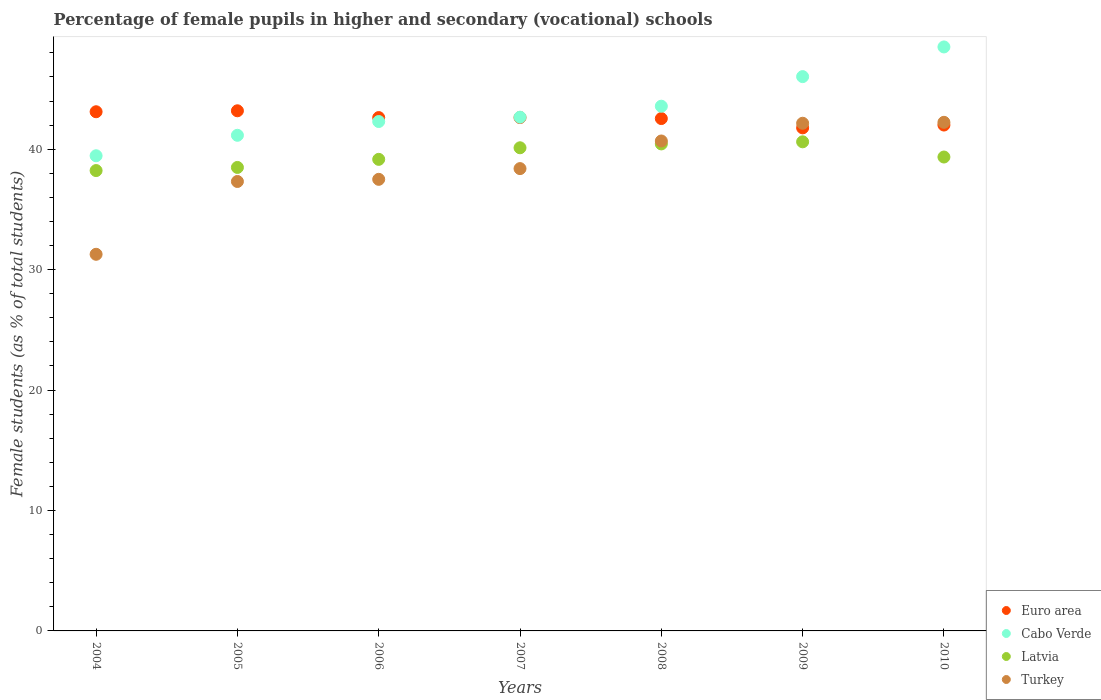How many different coloured dotlines are there?
Your answer should be very brief. 4. What is the percentage of female pupils in higher and secondary schools in Cabo Verde in 2008?
Your answer should be compact. 43.57. Across all years, what is the maximum percentage of female pupils in higher and secondary schools in Turkey?
Ensure brevity in your answer.  42.24. Across all years, what is the minimum percentage of female pupils in higher and secondary schools in Euro area?
Offer a terse response. 41.77. In which year was the percentage of female pupils in higher and secondary schools in Turkey maximum?
Offer a very short reply. 2010. What is the total percentage of female pupils in higher and secondary schools in Cabo Verde in the graph?
Offer a terse response. 303.68. What is the difference between the percentage of female pupils in higher and secondary schools in Latvia in 2004 and that in 2008?
Provide a short and direct response. -2.21. What is the difference between the percentage of female pupils in higher and secondary schools in Turkey in 2006 and the percentage of female pupils in higher and secondary schools in Latvia in 2008?
Your answer should be very brief. -2.94. What is the average percentage of female pupils in higher and secondary schools in Turkey per year?
Give a very brief answer. 38.51. In the year 2005, what is the difference between the percentage of female pupils in higher and secondary schools in Cabo Verde and percentage of female pupils in higher and secondary schools in Latvia?
Offer a terse response. 2.67. What is the ratio of the percentage of female pupils in higher and secondary schools in Turkey in 2004 to that in 2007?
Provide a short and direct response. 0.81. Is the percentage of female pupils in higher and secondary schools in Euro area in 2005 less than that in 2007?
Keep it short and to the point. No. What is the difference between the highest and the second highest percentage of female pupils in higher and secondary schools in Cabo Verde?
Offer a terse response. 2.46. What is the difference between the highest and the lowest percentage of female pupils in higher and secondary schools in Euro area?
Offer a terse response. 1.42. In how many years, is the percentage of female pupils in higher and secondary schools in Turkey greater than the average percentage of female pupils in higher and secondary schools in Turkey taken over all years?
Make the answer very short. 3. Is it the case that in every year, the sum of the percentage of female pupils in higher and secondary schools in Turkey and percentage of female pupils in higher and secondary schools in Cabo Verde  is greater than the percentage of female pupils in higher and secondary schools in Latvia?
Offer a terse response. Yes. Is the percentage of female pupils in higher and secondary schools in Latvia strictly less than the percentage of female pupils in higher and secondary schools in Turkey over the years?
Keep it short and to the point. No. How many years are there in the graph?
Offer a very short reply. 7. Where does the legend appear in the graph?
Offer a terse response. Bottom right. What is the title of the graph?
Offer a very short reply. Percentage of female pupils in higher and secondary (vocational) schools. Does "Tuvalu" appear as one of the legend labels in the graph?
Offer a very short reply. No. What is the label or title of the X-axis?
Offer a terse response. Years. What is the label or title of the Y-axis?
Offer a terse response. Female students (as % of total students). What is the Female students (as % of total students) in Euro area in 2004?
Your response must be concise. 43.11. What is the Female students (as % of total students) of Cabo Verde in 2004?
Provide a short and direct response. 39.46. What is the Female students (as % of total students) in Latvia in 2004?
Your answer should be compact. 38.23. What is the Female students (as % of total students) in Turkey in 2004?
Make the answer very short. 31.28. What is the Female students (as % of total students) in Euro area in 2005?
Offer a terse response. 43.19. What is the Female students (as % of total students) of Cabo Verde in 2005?
Ensure brevity in your answer.  41.16. What is the Female students (as % of total students) of Latvia in 2005?
Offer a terse response. 38.49. What is the Female students (as % of total students) in Turkey in 2005?
Give a very brief answer. 37.32. What is the Female students (as % of total students) of Euro area in 2006?
Your answer should be compact. 42.63. What is the Female students (as % of total students) of Cabo Verde in 2006?
Make the answer very short. 42.3. What is the Female students (as % of total students) of Latvia in 2006?
Your response must be concise. 39.16. What is the Female students (as % of total students) of Turkey in 2006?
Offer a very short reply. 37.5. What is the Female students (as % of total students) of Euro area in 2007?
Provide a succinct answer. 42.63. What is the Female students (as % of total students) of Cabo Verde in 2007?
Your answer should be very brief. 42.66. What is the Female students (as % of total students) in Latvia in 2007?
Provide a short and direct response. 40.12. What is the Female students (as % of total students) in Turkey in 2007?
Your answer should be very brief. 38.39. What is the Female students (as % of total students) of Euro area in 2008?
Keep it short and to the point. 42.55. What is the Female students (as % of total students) of Cabo Verde in 2008?
Offer a terse response. 43.57. What is the Female students (as % of total students) in Latvia in 2008?
Your response must be concise. 40.44. What is the Female students (as % of total students) in Turkey in 2008?
Make the answer very short. 40.69. What is the Female students (as % of total students) of Euro area in 2009?
Your answer should be very brief. 41.77. What is the Female students (as % of total students) of Cabo Verde in 2009?
Offer a very short reply. 46.03. What is the Female students (as % of total students) of Latvia in 2009?
Keep it short and to the point. 40.62. What is the Female students (as % of total students) in Turkey in 2009?
Make the answer very short. 42.16. What is the Female students (as % of total students) in Euro area in 2010?
Offer a very short reply. 42.01. What is the Female students (as % of total students) of Cabo Verde in 2010?
Provide a short and direct response. 48.5. What is the Female students (as % of total students) in Latvia in 2010?
Your answer should be compact. 39.35. What is the Female students (as % of total students) of Turkey in 2010?
Provide a short and direct response. 42.24. Across all years, what is the maximum Female students (as % of total students) of Euro area?
Offer a terse response. 43.19. Across all years, what is the maximum Female students (as % of total students) in Cabo Verde?
Make the answer very short. 48.5. Across all years, what is the maximum Female students (as % of total students) in Latvia?
Your answer should be compact. 40.62. Across all years, what is the maximum Female students (as % of total students) of Turkey?
Ensure brevity in your answer.  42.24. Across all years, what is the minimum Female students (as % of total students) in Euro area?
Your answer should be very brief. 41.77. Across all years, what is the minimum Female students (as % of total students) of Cabo Verde?
Make the answer very short. 39.46. Across all years, what is the minimum Female students (as % of total students) in Latvia?
Offer a very short reply. 38.23. Across all years, what is the minimum Female students (as % of total students) in Turkey?
Make the answer very short. 31.28. What is the total Female students (as % of total students) of Euro area in the graph?
Make the answer very short. 297.9. What is the total Female students (as % of total students) of Cabo Verde in the graph?
Offer a very short reply. 303.68. What is the total Female students (as % of total students) in Latvia in the graph?
Give a very brief answer. 276.41. What is the total Female students (as % of total students) of Turkey in the graph?
Provide a succinct answer. 269.57. What is the difference between the Female students (as % of total students) of Euro area in 2004 and that in 2005?
Offer a very short reply. -0.08. What is the difference between the Female students (as % of total students) in Cabo Verde in 2004 and that in 2005?
Offer a very short reply. -1.7. What is the difference between the Female students (as % of total students) of Latvia in 2004 and that in 2005?
Your answer should be compact. -0.26. What is the difference between the Female students (as % of total students) of Turkey in 2004 and that in 2005?
Keep it short and to the point. -6.05. What is the difference between the Female students (as % of total students) of Euro area in 2004 and that in 2006?
Give a very brief answer. 0.48. What is the difference between the Female students (as % of total students) in Cabo Verde in 2004 and that in 2006?
Ensure brevity in your answer.  -2.84. What is the difference between the Female students (as % of total students) in Latvia in 2004 and that in 2006?
Offer a terse response. -0.93. What is the difference between the Female students (as % of total students) in Turkey in 2004 and that in 2006?
Offer a very short reply. -6.22. What is the difference between the Female students (as % of total students) in Euro area in 2004 and that in 2007?
Provide a succinct answer. 0.48. What is the difference between the Female students (as % of total students) of Cabo Verde in 2004 and that in 2007?
Your answer should be very brief. -3.2. What is the difference between the Female students (as % of total students) of Latvia in 2004 and that in 2007?
Your response must be concise. -1.89. What is the difference between the Female students (as % of total students) in Turkey in 2004 and that in 2007?
Your answer should be very brief. -7.12. What is the difference between the Female students (as % of total students) in Euro area in 2004 and that in 2008?
Your answer should be compact. 0.57. What is the difference between the Female students (as % of total students) of Cabo Verde in 2004 and that in 2008?
Your answer should be very brief. -4.11. What is the difference between the Female students (as % of total students) of Latvia in 2004 and that in 2008?
Make the answer very short. -2.21. What is the difference between the Female students (as % of total students) in Turkey in 2004 and that in 2008?
Provide a succinct answer. -9.41. What is the difference between the Female students (as % of total students) of Euro area in 2004 and that in 2009?
Give a very brief answer. 1.34. What is the difference between the Female students (as % of total students) in Cabo Verde in 2004 and that in 2009?
Provide a short and direct response. -6.57. What is the difference between the Female students (as % of total students) in Latvia in 2004 and that in 2009?
Your response must be concise. -2.39. What is the difference between the Female students (as % of total students) of Turkey in 2004 and that in 2009?
Keep it short and to the point. -10.88. What is the difference between the Female students (as % of total students) of Euro area in 2004 and that in 2010?
Offer a terse response. 1.1. What is the difference between the Female students (as % of total students) of Cabo Verde in 2004 and that in 2010?
Ensure brevity in your answer.  -9.04. What is the difference between the Female students (as % of total students) of Latvia in 2004 and that in 2010?
Keep it short and to the point. -1.12. What is the difference between the Female students (as % of total students) of Turkey in 2004 and that in 2010?
Your answer should be very brief. -10.96. What is the difference between the Female students (as % of total students) in Euro area in 2005 and that in 2006?
Keep it short and to the point. 0.56. What is the difference between the Female students (as % of total students) in Cabo Verde in 2005 and that in 2006?
Provide a short and direct response. -1.14. What is the difference between the Female students (as % of total students) of Latvia in 2005 and that in 2006?
Your response must be concise. -0.67. What is the difference between the Female students (as % of total students) in Turkey in 2005 and that in 2006?
Keep it short and to the point. -0.18. What is the difference between the Female students (as % of total students) of Euro area in 2005 and that in 2007?
Ensure brevity in your answer.  0.56. What is the difference between the Female students (as % of total students) in Cabo Verde in 2005 and that in 2007?
Ensure brevity in your answer.  -1.5. What is the difference between the Female students (as % of total students) of Latvia in 2005 and that in 2007?
Ensure brevity in your answer.  -1.63. What is the difference between the Female students (as % of total students) of Turkey in 2005 and that in 2007?
Provide a succinct answer. -1.07. What is the difference between the Female students (as % of total students) of Euro area in 2005 and that in 2008?
Provide a succinct answer. 0.65. What is the difference between the Female students (as % of total students) in Cabo Verde in 2005 and that in 2008?
Your answer should be very brief. -2.42. What is the difference between the Female students (as % of total students) in Latvia in 2005 and that in 2008?
Your answer should be compact. -1.95. What is the difference between the Female students (as % of total students) in Turkey in 2005 and that in 2008?
Your answer should be very brief. -3.36. What is the difference between the Female students (as % of total students) of Euro area in 2005 and that in 2009?
Your answer should be very brief. 1.42. What is the difference between the Female students (as % of total students) in Cabo Verde in 2005 and that in 2009?
Ensure brevity in your answer.  -4.87. What is the difference between the Female students (as % of total students) of Latvia in 2005 and that in 2009?
Your answer should be very brief. -2.13. What is the difference between the Female students (as % of total students) in Turkey in 2005 and that in 2009?
Your response must be concise. -4.84. What is the difference between the Female students (as % of total students) of Euro area in 2005 and that in 2010?
Offer a very short reply. 1.18. What is the difference between the Female students (as % of total students) of Cabo Verde in 2005 and that in 2010?
Keep it short and to the point. -7.34. What is the difference between the Female students (as % of total students) of Latvia in 2005 and that in 2010?
Ensure brevity in your answer.  -0.86. What is the difference between the Female students (as % of total students) of Turkey in 2005 and that in 2010?
Make the answer very short. -4.91. What is the difference between the Female students (as % of total students) in Euro area in 2006 and that in 2007?
Ensure brevity in your answer.  -0. What is the difference between the Female students (as % of total students) of Cabo Verde in 2006 and that in 2007?
Offer a terse response. -0.36. What is the difference between the Female students (as % of total students) of Latvia in 2006 and that in 2007?
Your answer should be compact. -0.96. What is the difference between the Female students (as % of total students) in Turkey in 2006 and that in 2007?
Provide a succinct answer. -0.89. What is the difference between the Female students (as % of total students) of Euro area in 2006 and that in 2008?
Give a very brief answer. 0.08. What is the difference between the Female students (as % of total students) in Cabo Verde in 2006 and that in 2008?
Provide a short and direct response. -1.27. What is the difference between the Female students (as % of total students) of Latvia in 2006 and that in 2008?
Your answer should be very brief. -1.28. What is the difference between the Female students (as % of total students) in Turkey in 2006 and that in 2008?
Give a very brief answer. -3.18. What is the difference between the Female students (as % of total students) of Euro area in 2006 and that in 2009?
Keep it short and to the point. 0.85. What is the difference between the Female students (as % of total students) in Cabo Verde in 2006 and that in 2009?
Offer a very short reply. -3.73. What is the difference between the Female students (as % of total students) of Latvia in 2006 and that in 2009?
Provide a short and direct response. -1.46. What is the difference between the Female students (as % of total students) in Turkey in 2006 and that in 2009?
Offer a very short reply. -4.66. What is the difference between the Female students (as % of total students) of Euro area in 2006 and that in 2010?
Provide a short and direct response. 0.62. What is the difference between the Female students (as % of total students) in Cabo Verde in 2006 and that in 2010?
Ensure brevity in your answer.  -6.19. What is the difference between the Female students (as % of total students) in Latvia in 2006 and that in 2010?
Offer a very short reply. -0.19. What is the difference between the Female students (as % of total students) of Turkey in 2006 and that in 2010?
Offer a terse response. -4.73. What is the difference between the Female students (as % of total students) in Euro area in 2007 and that in 2008?
Your response must be concise. 0.08. What is the difference between the Female students (as % of total students) in Cabo Verde in 2007 and that in 2008?
Keep it short and to the point. -0.91. What is the difference between the Female students (as % of total students) in Latvia in 2007 and that in 2008?
Offer a very short reply. -0.32. What is the difference between the Female students (as % of total students) in Turkey in 2007 and that in 2008?
Ensure brevity in your answer.  -2.29. What is the difference between the Female students (as % of total students) of Euro area in 2007 and that in 2009?
Offer a very short reply. 0.86. What is the difference between the Female students (as % of total students) in Cabo Verde in 2007 and that in 2009?
Offer a terse response. -3.37. What is the difference between the Female students (as % of total students) in Latvia in 2007 and that in 2009?
Make the answer very short. -0.5. What is the difference between the Female students (as % of total students) of Turkey in 2007 and that in 2009?
Provide a short and direct response. -3.77. What is the difference between the Female students (as % of total students) in Euro area in 2007 and that in 2010?
Provide a succinct answer. 0.62. What is the difference between the Female students (as % of total students) in Cabo Verde in 2007 and that in 2010?
Keep it short and to the point. -5.83. What is the difference between the Female students (as % of total students) in Latvia in 2007 and that in 2010?
Give a very brief answer. 0.77. What is the difference between the Female students (as % of total students) in Turkey in 2007 and that in 2010?
Keep it short and to the point. -3.84. What is the difference between the Female students (as % of total students) in Euro area in 2008 and that in 2009?
Keep it short and to the point. 0.77. What is the difference between the Female students (as % of total students) of Cabo Verde in 2008 and that in 2009?
Provide a short and direct response. -2.46. What is the difference between the Female students (as % of total students) of Latvia in 2008 and that in 2009?
Provide a succinct answer. -0.17. What is the difference between the Female students (as % of total students) in Turkey in 2008 and that in 2009?
Give a very brief answer. -1.47. What is the difference between the Female students (as % of total students) in Euro area in 2008 and that in 2010?
Your answer should be very brief. 0.54. What is the difference between the Female students (as % of total students) in Cabo Verde in 2008 and that in 2010?
Provide a short and direct response. -4.92. What is the difference between the Female students (as % of total students) of Latvia in 2008 and that in 2010?
Provide a succinct answer. 1.09. What is the difference between the Female students (as % of total students) of Turkey in 2008 and that in 2010?
Give a very brief answer. -1.55. What is the difference between the Female students (as % of total students) in Euro area in 2009 and that in 2010?
Offer a terse response. -0.23. What is the difference between the Female students (as % of total students) of Cabo Verde in 2009 and that in 2010?
Offer a very short reply. -2.46. What is the difference between the Female students (as % of total students) of Latvia in 2009 and that in 2010?
Give a very brief answer. 1.26. What is the difference between the Female students (as % of total students) of Turkey in 2009 and that in 2010?
Give a very brief answer. -0.08. What is the difference between the Female students (as % of total students) in Euro area in 2004 and the Female students (as % of total students) in Cabo Verde in 2005?
Keep it short and to the point. 1.96. What is the difference between the Female students (as % of total students) of Euro area in 2004 and the Female students (as % of total students) of Latvia in 2005?
Ensure brevity in your answer.  4.62. What is the difference between the Female students (as % of total students) of Euro area in 2004 and the Female students (as % of total students) of Turkey in 2005?
Your answer should be very brief. 5.79. What is the difference between the Female students (as % of total students) in Cabo Verde in 2004 and the Female students (as % of total students) in Latvia in 2005?
Provide a short and direct response. 0.97. What is the difference between the Female students (as % of total students) of Cabo Verde in 2004 and the Female students (as % of total students) of Turkey in 2005?
Your answer should be very brief. 2.14. What is the difference between the Female students (as % of total students) of Latvia in 2004 and the Female students (as % of total students) of Turkey in 2005?
Keep it short and to the point. 0.91. What is the difference between the Female students (as % of total students) in Euro area in 2004 and the Female students (as % of total students) in Cabo Verde in 2006?
Your answer should be compact. 0.81. What is the difference between the Female students (as % of total students) of Euro area in 2004 and the Female students (as % of total students) of Latvia in 2006?
Give a very brief answer. 3.95. What is the difference between the Female students (as % of total students) in Euro area in 2004 and the Female students (as % of total students) in Turkey in 2006?
Ensure brevity in your answer.  5.61. What is the difference between the Female students (as % of total students) of Cabo Verde in 2004 and the Female students (as % of total students) of Latvia in 2006?
Provide a succinct answer. 0.3. What is the difference between the Female students (as % of total students) of Cabo Verde in 2004 and the Female students (as % of total students) of Turkey in 2006?
Your answer should be very brief. 1.96. What is the difference between the Female students (as % of total students) in Latvia in 2004 and the Female students (as % of total students) in Turkey in 2006?
Your answer should be compact. 0.73. What is the difference between the Female students (as % of total students) in Euro area in 2004 and the Female students (as % of total students) in Cabo Verde in 2007?
Your answer should be compact. 0.45. What is the difference between the Female students (as % of total students) of Euro area in 2004 and the Female students (as % of total students) of Latvia in 2007?
Keep it short and to the point. 2.99. What is the difference between the Female students (as % of total students) of Euro area in 2004 and the Female students (as % of total students) of Turkey in 2007?
Your response must be concise. 4.72. What is the difference between the Female students (as % of total students) in Cabo Verde in 2004 and the Female students (as % of total students) in Latvia in 2007?
Your answer should be compact. -0.66. What is the difference between the Female students (as % of total students) in Cabo Verde in 2004 and the Female students (as % of total students) in Turkey in 2007?
Keep it short and to the point. 1.07. What is the difference between the Female students (as % of total students) in Latvia in 2004 and the Female students (as % of total students) in Turkey in 2007?
Make the answer very short. -0.16. What is the difference between the Female students (as % of total students) of Euro area in 2004 and the Female students (as % of total students) of Cabo Verde in 2008?
Ensure brevity in your answer.  -0.46. What is the difference between the Female students (as % of total students) in Euro area in 2004 and the Female students (as % of total students) in Latvia in 2008?
Your response must be concise. 2.67. What is the difference between the Female students (as % of total students) of Euro area in 2004 and the Female students (as % of total students) of Turkey in 2008?
Your answer should be very brief. 2.43. What is the difference between the Female students (as % of total students) in Cabo Verde in 2004 and the Female students (as % of total students) in Latvia in 2008?
Provide a short and direct response. -0.98. What is the difference between the Female students (as % of total students) in Cabo Verde in 2004 and the Female students (as % of total students) in Turkey in 2008?
Keep it short and to the point. -1.23. What is the difference between the Female students (as % of total students) in Latvia in 2004 and the Female students (as % of total students) in Turkey in 2008?
Give a very brief answer. -2.46. What is the difference between the Female students (as % of total students) in Euro area in 2004 and the Female students (as % of total students) in Cabo Verde in 2009?
Offer a terse response. -2.92. What is the difference between the Female students (as % of total students) in Euro area in 2004 and the Female students (as % of total students) in Latvia in 2009?
Ensure brevity in your answer.  2.5. What is the difference between the Female students (as % of total students) in Euro area in 2004 and the Female students (as % of total students) in Turkey in 2009?
Give a very brief answer. 0.95. What is the difference between the Female students (as % of total students) of Cabo Verde in 2004 and the Female students (as % of total students) of Latvia in 2009?
Offer a very short reply. -1.16. What is the difference between the Female students (as % of total students) in Cabo Verde in 2004 and the Female students (as % of total students) in Turkey in 2009?
Your answer should be very brief. -2.7. What is the difference between the Female students (as % of total students) of Latvia in 2004 and the Female students (as % of total students) of Turkey in 2009?
Offer a terse response. -3.93. What is the difference between the Female students (as % of total students) in Euro area in 2004 and the Female students (as % of total students) in Cabo Verde in 2010?
Make the answer very short. -5.38. What is the difference between the Female students (as % of total students) in Euro area in 2004 and the Female students (as % of total students) in Latvia in 2010?
Your answer should be compact. 3.76. What is the difference between the Female students (as % of total students) in Euro area in 2004 and the Female students (as % of total students) in Turkey in 2010?
Provide a short and direct response. 0.88. What is the difference between the Female students (as % of total students) of Cabo Verde in 2004 and the Female students (as % of total students) of Latvia in 2010?
Your response must be concise. 0.11. What is the difference between the Female students (as % of total students) of Cabo Verde in 2004 and the Female students (as % of total students) of Turkey in 2010?
Provide a succinct answer. -2.78. What is the difference between the Female students (as % of total students) of Latvia in 2004 and the Female students (as % of total students) of Turkey in 2010?
Offer a terse response. -4.01. What is the difference between the Female students (as % of total students) of Euro area in 2005 and the Female students (as % of total students) of Cabo Verde in 2006?
Provide a succinct answer. 0.89. What is the difference between the Female students (as % of total students) in Euro area in 2005 and the Female students (as % of total students) in Latvia in 2006?
Make the answer very short. 4.03. What is the difference between the Female students (as % of total students) of Euro area in 2005 and the Female students (as % of total students) of Turkey in 2006?
Provide a short and direct response. 5.69. What is the difference between the Female students (as % of total students) in Cabo Verde in 2005 and the Female students (as % of total students) in Latvia in 2006?
Your answer should be compact. 2. What is the difference between the Female students (as % of total students) in Cabo Verde in 2005 and the Female students (as % of total students) in Turkey in 2006?
Provide a short and direct response. 3.66. What is the difference between the Female students (as % of total students) in Euro area in 2005 and the Female students (as % of total students) in Cabo Verde in 2007?
Keep it short and to the point. 0.53. What is the difference between the Female students (as % of total students) of Euro area in 2005 and the Female students (as % of total students) of Latvia in 2007?
Provide a succinct answer. 3.07. What is the difference between the Female students (as % of total students) of Euro area in 2005 and the Female students (as % of total students) of Turkey in 2007?
Your response must be concise. 4.8. What is the difference between the Female students (as % of total students) in Cabo Verde in 2005 and the Female students (as % of total students) in Latvia in 2007?
Offer a very short reply. 1.04. What is the difference between the Female students (as % of total students) of Cabo Verde in 2005 and the Female students (as % of total students) of Turkey in 2007?
Make the answer very short. 2.77. What is the difference between the Female students (as % of total students) in Latvia in 2005 and the Female students (as % of total students) in Turkey in 2007?
Provide a succinct answer. 0.1. What is the difference between the Female students (as % of total students) of Euro area in 2005 and the Female students (as % of total students) of Cabo Verde in 2008?
Make the answer very short. -0.38. What is the difference between the Female students (as % of total students) in Euro area in 2005 and the Female students (as % of total students) in Latvia in 2008?
Keep it short and to the point. 2.75. What is the difference between the Female students (as % of total students) in Euro area in 2005 and the Female students (as % of total students) in Turkey in 2008?
Offer a very short reply. 2.51. What is the difference between the Female students (as % of total students) of Cabo Verde in 2005 and the Female students (as % of total students) of Latvia in 2008?
Offer a terse response. 0.72. What is the difference between the Female students (as % of total students) of Cabo Verde in 2005 and the Female students (as % of total students) of Turkey in 2008?
Your answer should be compact. 0.47. What is the difference between the Female students (as % of total students) in Latvia in 2005 and the Female students (as % of total students) in Turkey in 2008?
Ensure brevity in your answer.  -2.2. What is the difference between the Female students (as % of total students) in Euro area in 2005 and the Female students (as % of total students) in Cabo Verde in 2009?
Offer a very short reply. -2.84. What is the difference between the Female students (as % of total students) of Euro area in 2005 and the Female students (as % of total students) of Latvia in 2009?
Give a very brief answer. 2.58. What is the difference between the Female students (as % of total students) in Euro area in 2005 and the Female students (as % of total students) in Turkey in 2009?
Your response must be concise. 1.03. What is the difference between the Female students (as % of total students) of Cabo Verde in 2005 and the Female students (as % of total students) of Latvia in 2009?
Your answer should be compact. 0.54. What is the difference between the Female students (as % of total students) in Cabo Verde in 2005 and the Female students (as % of total students) in Turkey in 2009?
Your answer should be compact. -1. What is the difference between the Female students (as % of total students) of Latvia in 2005 and the Female students (as % of total students) of Turkey in 2009?
Ensure brevity in your answer.  -3.67. What is the difference between the Female students (as % of total students) in Euro area in 2005 and the Female students (as % of total students) in Cabo Verde in 2010?
Provide a succinct answer. -5.3. What is the difference between the Female students (as % of total students) of Euro area in 2005 and the Female students (as % of total students) of Latvia in 2010?
Keep it short and to the point. 3.84. What is the difference between the Female students (as % of total students) in Euro area in 2005 and the Female students (as % of total students) in Turkey in 2010?
Your answer should be very brief. 0.96. What is the difference between the Female students (as % of total students) in Cabo Verde in 2005 and the Female students (as % of total students) in Latvia in 2010?
Your response must be concise. 1.8. What is the difference between the Female students (as % of total students) of Cabo Verde in 2005 and the Female students (as % of total students) of Turkey in 2010?
Offer a terse response. -1.08. What is the difference between the Female students (as % of total students) of Latvia in 2005 and the Female students (as % of total students) of Turkey in 2010?
Your answer should be very brief. -3.75. What is the difference between the Female students (as % of total students) of Euro area in 2006 and the Female students (as % of total students) of Cabo Verde in 2007?
Provide a succinct answer. -0.03. What is the difference between the Female students (as % of total students) of Euro area in 2006 and the Female students (as % of total students) of Latvia in 2007?
Your answer should be compact. 2.51. What is the difference between the Female students (as % of total students) of Euro area in 2006 and the Female students (as % of total students) of Turkey in 2007?
Your response must be concise. 4.24. What is the difference between the Female students (as % of total students) in Cabo Verde in 2006 and the Female students (as % of total students) in Latvia in 2007?
Provide a short and direct response. 2.18. What is the difference between the Female students (as % of total students) of Cabo Verde in 2006 and the Female students (as % of total students) of Turkey in 2007?
Your response must be concise. 3.91. What is the difference between the Female students (as % of total students) of Latvia in 2006 and the Female students (as % of total students) of Turkey in 2007?
Your answer should be compact. 0.77. What is the difference between the Female students (as % of total students) of Euro area in 2006 and the Female students (as % of total students) of Cabo Verde in 2008?
Your answer should be compact. -0.94. What is the difference between the Female students (as % of total students) in Euro area in 2006 and the Female students (as % of total students) in Latvia in 2008?
Offer a terse response. 2.19. What is the difference between the Female students (as % of total students) in Euro area in 2006 and the Female students (as % of total students) in Turkey in 2008?
Ensure brevity in your answer.  1.94. What is the difference between the Female students (as % of total students) of Cabo Verde in 2006 and the Female students (as % of total students) of Latvia in 2008?
Your response must be concise. 1.86. What is the difference between the Female students (as % of total students) in Cabo Verde in 2006 and the Female students (as % of total students) in Turkey in 2008?
Make the answer very short. 1.62. What is the difference between the Female students (as % of total students) of Latvia in 2006 and the Female students (as % of total students) of Turkey in 2008?
Make the answer very short. -1.52. What is the difference between the Female students (as % of total students) in Euro area in 2006 and the Female students (as % of total students) in Cabo Verde in 2009?
Your response must be concise. -3.4. What is the difference between the Female students (as % of total students) in Euro area in 2006 and the Female students (as % of total students) in Latvia in 2009?
Provide a succinct answer. 2.01. What is the difference between the Female students (as % of total students) of Euro area in 2006 and the Female students (as % of total students) of Turkey in 2009?
Offer a very short reply. 0.47. What is the difference between the Female students (as % of total students) in Cabo Verde in 2006 and the Female students (as % of total students) in Latvia in 2009?
Keep it short and to the point. 1.69. What is the difference between the Female students (as % of total students) of Cabo Verde in 2006 and the Female students (as % of total students) of Turkey in 2009?
Provide a short and direct response. 0.14. What is the difference between the Female students (as % of total students) of Latvia in 2006 and the Female students (as % of total students) of Turkey in 2009?
Offer a terse response. -3. What is the difference between the Female students (as % of total students) of Euro area in 2006 and the Female students (as % of total students) of Cabo Verde in 2010?
Give a very brief answer. -5.87. What is the difference between the Female students (as % of total students) in Euro area in 2006 and the Female students (as % of total students) in Latvia in 2010?
Your answer should be very brief. 3.28. What is the difference between the Female students (as % of total students) in Euro area in 2006 and the Female students (as % of total students) in Turkey in 2010?
Ensure brevity in your answer.  0.39. What is the difference between the Female students (as % of total students) in Cabo Verde in 2006 and the Female students (as % of total students) in Latvia in 2010?
Provide a short and direct response. 2.95. What is the difference between the Female students (as % of total students) in Cabo Verde in 2006 and the Female students (as % of total students) in Turkey in 2010?
Your response must be concise. 0.07. What is the difference between the Female students (as % of total students) of Latvia in 2006 and the Female students (as % of total students) of Turkey in 2010?
Provide a succinct answer. -3.08. What is the difference between the Female students (as % of total students) in Euro area in 2007 and the Female students (as % of total students) in Cabo Verde in 2008?
Give a very brief answer. -0.94. What is the difference between the Female students (as % of total students) of Euro area in 2007 and the Female students (as % of total students) of Latvia in 2008?
Your response must be concise. 2.19. What is the difference between the Female students (as % of total students) of Euro area in 2007 and the Female students (as % of total students) of Turkey in 2008?
Give a very brief answer. 1.95. What is the difference between the Female students (as % of total students) of Cabo Verde in 2007 and the Female students (as % of total students) of Latvia in 2008?
Ensure brevity in your answer.  2.22. What is the difference between the Female students (as % of total students) in Cabo Verde in 2007 and the Female students (as % of total students) in Turkey in 2008?
Ensure brevity in your answer.  1.98. What is the difference between the Female students (as % of total students) of Latvia in 2007 and the Female students (as % of total students) of Turkey in 2008?
Your answer should be very brief. -0.56. What is the difference between the Female students (as % of total students) of Euro area in 2007 and the Female students (as % of total students) of Cabo Verde in 2009?
Ensure brevity in your answer.  -3.4. What is the difference between the Female students (as % of total students) in Euro area in 2007 and the Female students (as % of total students) in Latvia in 2009?
Your response must be concise. 2.02. What is the difference between the Female students (as % of total students) of Euro area in 2007 and the Female students (as % of total students) of Turkey in 2009?
Make the answer very short. 0.47. What is the difference between the Female students (as % of total students) of Cabo Verde in 2007 and the Female students (as % of total students) of Latvia in 2009?
Give a very brief answer. 2.04. What is the difference between the Female students (as % of total students) in Cabo Verde in 2007 and the Female students (as % of total students) in Turkey in 2009?
Keep it short and to the point. 0.5. What is the difference between the Female students (as % of total students) of Latvia in 2007 and the Female students (as % of total students) of Turkey in 2009?
Your answer should be very brief. -2.04. What is the difference between the Female students (as % of total students) of Euro area in 2007 and the Female students (as % of total students) of Cabo Verde in 2010?
Make the answer very short. -5.86. What is the difference between the Female students (as % of total students) in Euro area in 2007 and the Female students (as % of total students) in Latvia in 2010?
Offer a terse response. 3.28. What is the difference between the Female students (as % of total students) in Euro area in 2007 and the Female students (as % of total students) in Turkey in 2010?
Make the answer very short. 0.4. What is the difference between the Female students (as % of total students) in Cabo Verde in 2007 and the Female students (as % of total students) in Latvia in 2010?
Your response must be concise. 3.31. What is the difference between the Female students (as % of total students) in Cabo Verde in 2007 and the Female students (as % of total students) in Turkey in 2010?
Offer a terse response. 0.43. What is the difference between the Female students (as % of total students) of Latvia in 2007 and the Female students (as % of total students) of Turkey in 2010?
Ensure brevity in your answer.  -2.11. What is the difference between the Female students (as % of total students) in Euro area in 2008 and the Female students (as % of total students) in Cabo Verde in 2009?
Offer a terse response. -3.48. What is the difference between the Female students (as % of total students) of Euro area in 2008 and the Female students (as % of total students) of Latvia in 2009?
Make the answer very short. 1.93. What is the difference between the Female students (as % of total students) of Euro area in 2008 and the Female students (as % of total students) of Turkey in 2009?
Provide a succinct answer. 0.39. What is the difference between the Female students (as % of total students) in Cabo Verde in 2008 and the Female students (as % of total students) in Latvia in 2009?
Give a very brief answer. 2.96. What is the difference between the Female students (as % of total students) in Cabo Verde in 2008 and the Female students (as % of total students) in Turkey in 2009?
Make the answer very short. 1.42. What is the difference between the Female students (as % of total students) in Latvia in 2008 and the Female students (as % of total students) in Turkey in 2009?
Your answer should be very brief. -1.72. What is the difference between the Female students (as % of total students) of Euro area in 2008 and the Female students (as % of total students) of Cabo Verde in 2010?
Provide a succinct answer. -5.95. What is the difference between the Female students (as % of total students) of Euro area in 2008 and the Female students (as % of total students) of Latvia in 2010?
Your answer should be very brief. 3.19. What is the difference between the Female students (as % of total students) of Euro area in 2008 and the Female students (as % of total students) of Turkey in 2010?
Offer a very short reply. 0.31. What is the difference between the Female students (as % of total students) of Cabo Verde in 2008 and the Female students (as % of total students) of Latvia in 2010?
Make the answer very short. 4.22. What is the difference between the Female students (as % of total students) of Cabo Verde in 2008 and the Female students (as % of total students) of Turkey in 2010?
Keep it short and to the point. 1.34. What is the difference between the Female students (as % of total students) of Latvia in 2008 and the Female students (as % of total students) of Turkey in 2010?
Ensure brevity in your answer.  -1.79. What is the difference between the Female students (as % of total students) of Euro area in 2009 and the Female students (as % of total students) of Cabo Verde in 2010?
Provide a short and direct response. -6.72. What is the difference between the Female students (as % of total students) of Euro area in 2009 and the Female students (as % of total students) of Latvia in 2010?
Provide a short and direct response. 2.42. What is the difference between the Female students (as % of total students) in Euro area in 2009 and the Female students (as % of total students) in Turkey in 2010?
Ensure brevity in your answer.  -0.46. What is the difference between the Female students (as % of total students) of Cabo Verde in 2009 and the Female students (as % of total students) of Latvia in 2010?
Make the answer very short. 6.68. What is the difference between the Female students (as % of total students) of Cabo Verde in 2009 and the Female students (as % of total students) of Turkey in 2010?
Provide a succinct answer. 3.79. What is the difference between the Female students (as % of total students) in Latvia in 2009 and the Female students (as % of total students) in Turkey in 2010?
Provide a succinct answer. -1.62. What is the average Female students (as % of total students) in Euro area per year?
Your answer should be compact. 42.56. What is the average Female students (as % of total students) in Cabo Verde per year?
Provide a short and direct response. 43.38. What is the average Female students (as % of total students) in Latvia per year?
Offer a terse response. 39.49. What is the average Female students (as % of total students) in Turkey per year?
Ensure brevity in your answer.  38.51. In the year 2004, what is the difference between the Female students (as % of total students) of Euro area and Female students (as % of total students) of Cabo Verde?
Give a very brief answer. 3.65. In the year 2004, what is the difference between the Female students (as % of total students) in Euro area and Female students (as % of total students) in Latvia?
Keep it short and to the point. 4.88. In the year 2004, what is the difference between the Female students (as % of total students) of Euro area and Female students (as % of total students) of Turkey?
Your answer should be very brief. 11.84. In the year 2004, what is the difference between the Female students (as % of total students) of Cabo Verde and Female students (as % of total students) of Latvia?
Your answer should be compact. 1.23. In the year 2004, what is the difference between the Female students (as % of total students) in Cabo Verde and Female students (as % of total students) in Turkey?
Provide a succinct answer. 8.18. In the year 2004, what is the difference between the Female students (as % of total students) in Latvia and Female students (as % of total students) in Turkey?
Your response must be concise. 6.95. In the year 2005, what is the difference between the Female students (as % of total students) of Euro area and Female students (as % of total students) of Cabo Verde?
Your response must be concise. 2.04. In the year 2005, what is the difference between the Female students (as % of total students) of Euro area and Female students (as % of total students) of Latvia?
Provide a short and direct response. 4.7. In the year 2005, what is the difference between the Female students (as % of total students) in Euro area and Female students (as % of total students) in Turkey?
Provide a short and direct response. 5.87. In the year 2005, what is the difference between the Female students (as % of total students) in Cabo Verde and Female students (as % of total students) in Latvia?
Provide a succinct answer. 2.67. In the year 2005, what is the difference between the Female students (as % of total students) of Cabo Verde and Female students (as % of total students) of Turkey?
Ensure brevity in your answer.  3.84. In the year 2005, what is the difference between the Female students (as % of total students) in Latvia and Female students (as % of total students) in Turkey?
Ensure brevity in your answer.  1.17. In the year 2006, what is the difference between the Female students (as % of total students) of Euro area and Female students (as % of total students) of Cabo Verde?
Your response must be concise. 0.33. In the year 2006, what is the difference between the Female students (as % of total students) of Euro area and Female students (as % of total students) of Latvia?
Offer a terse response. 3.47. In the year 2006, what is the difference between the Female students (as % of total students) of Euro area and Female students (as % of total students) of Turkey?
Provide a succinct answer. 5.13. In the year 2006, what is the difference between the Female students (as % of total students) in Cabo Verde and Female students (as % of total students) in Latvia?
Your answer should be very brief. 3.14. In the year 2006, what is the difference between the Female students (as % of total students) in Cabo Verde and Female students (as % of total students) in Turkey?
Make the answer very short. 4.8. In the year 2006, what is the difference between the Female students (as % of total students) in Latvia and Female students (as % of total students) in Turkey?
Offer a very short reply. 1.66. In the year 2007, what is the difference between the Female students (as % of total students) in Euro area and Female students (as % of total students) in Cabo Verde?
Provide a short and direct response. -0.03. In the year 2007, what is the difference between the Female students (as % of total students) in Euro area and Female students (as % of total students) in Latvia?
Provide a succinct answer. 2.51. In the year 2007, what is the difference between the Female students (as % of total students) of Euro area and Female students (as % of total students) of Turkey?
Offer a very short reply. 4.24. In the year 2007, what is the difference between the Female students (as % of total students) of Cabo Verde and Female students (as % of total students) of Latvia?
Your response must be concise. 2.54. In the year 2007, what is the difference between the Female students (as % of total students) in Cabo Verde and Female students (as % of total students) in Turkey?
Your response must be concise. 4.27. In the year 2007, what is the difference between the Female students (as % of total students) in Latvia and Female students (as % of total students) in Turkey?
Offer a terse response. 1.73. In the year 2008, what is the difference between the Female students (as % of total students) of Euro area and Female students (as % of total students) of Cabo Verde?
Offer a terse response. -1.03. In the year 2008, what is the difference between the Female students (as % of total students) in Euro area and Female students (as % of total students) in Latvia?
Your answer should be very brief. 2.11. In the year 2008, what is the difference between the Female students (as % of total students) in Euro area and Female students (as % of total students) in Turkey?
Offer a very short reply. 1.86. In the year 2008, what is the difference between the Female students (as % of total students) in Cabo Verde and Female students (as % of total students) in Latvia?
Offer a very short reply. 3.13. In the year 2008, what is the difference between the Female students (as % of total students) in Cabo Verde and Female students (as % of total students) in Turkey?
Make the answer very short. 2.89. In the year 2008, what is the difference between the Female students (as % of total students) in Latvia and Female students (as % of total students) in Turkey?
Keep it short and to the point. -0.24. In the year 2009, what is the difference between the Female students (as % of total students) in Euro area and Female students (as % of total students) in Cabo Verde?
Offer a very short reply. -4.26. In the year 2009, what is the difference between the Female students (as % of total students) of Euro area and Female students (as % of total students) of Latvia?
Your response must be concise. 1.16. In the year 2009, what is the difference between the Female students (as % of total students) in Euro area and Female students (as % of total students) in Turkey?
Keep it short and to the point. -0.38. In the year 2009, what is the difference between the Female students (as % of total students) in Cabo Verde and Female students (as % of total students) in Latvia?
Your response must be concise. 5.41. In the year 2009, what is the difference between the Female students (as % of total students) in Cabo Verde and Female students (as % of total students) in Turkey?
Give a very brief answer. 3.87. In the year 2009, what is the difference between the Female students (as % of total students) in Latvia and Female students (as % of total students) in Turkey?
Ensure brevity in your answer.  -1.54. In the year 2010, what is the difference between the Female students (as % of total students) in Euro area and Female students (as % of total students) in Cabo Verde?
Your answer should be very brief. -6.49. In the year 2010, what is the difference between the Female students (as % of total students) in Euro area and Female students (as % of total students) in Latvia?
Give a very brief answer. 2.66. In the year 2010, what is the difference between the Female students (as % of total students) of Euro area and Female students (as % of total students) of Turkey?
Your answer should be very brief. -0.23. In the year 2010, what is the difference between the Female students (as % of total students) of Cabo Verde and Female students (as % of total students) of Latvia?
Offer a terse response. 9.14. In the year 2010, what is the difference between the Female students (as % of total students) of Cabo Verde and Female students (as % of total students) of Turkey?
Keep it short and to the point. 6.26. In the year 2010, what is the difference between the Female students (as % of total students) in Latvia and Female students (as % of total students) in Turkey?
Offer a very short reply. -2.88. What is the ratio of the Female students (as % of total students) in Cabo Verde in 2004 to that in 2005?
Offer a terse response. 0.96. What is the ratio of the Female students (as % of total students) of Turkey in 2004 to that in 2005?
Make the answer very short. 0.84. What is the ratio of the Female students (as % of total students) of Euro area in 2004 to that in 2006?
Offer a terse response. 1.01. What is the ratio of the Female students (as % of total students) of Cabo Verde in 2004 to that in 2006?
Offer a terse response. 0.93. What is the ratio of the Female students (as % of total students) in Latvia in 2004 to that in 2006?
Offer a terse response. 0.98. What is the ratio of the Female students (as % of total students) of Turkey in 2004 to that in 2006?
Ensure brevity in your answer.  0.83. What is the ratio of the Female students (as % of total students) of Euro area in 2004 to that in 2007?
Your answer should be very brief. 1.01. What is the ratio of the Female students (as % of total students) of Cabo Verde in 2004 to that in 2007?
Ensure brevity in your answer.  0.92. What is the ratio of the Female students (as % of total students) in Latvia in 2004 to that in 2007?
Offer a terse response. 0.95. What is the ratio of the Female students (as % of total students) in Turkey in 2004 to that in 2007?
Your response must be concise. 0.81. What is the ratio of the Female students (as % of total students) in Euro area in 2004 to that in 2008?
Offer a terse response. 1.01. What is the ratio of the Female students (as % of total students) in Cabo Verde in 2004 to that in 2008?
Make the answer very short. 0.91. What is the ratio of the Female students (as % of total students) of Latvia in 2004 to that in 2008?
Your answer should be compact. 0.95. What is the ratio of the Female students (as % of total students) in Turkey in 2004 to that in 2008?
Give a very brief answer. 0.77. What is the ratio of the Female students (as % of total students) of Euro area in 2004 to that in 2009?
Offer a terse response. 1.03. What is the ratio of the Female students (as % of total students) of Cabo Verde in 2004 to that in 2009?
Your answer should be very brief. 0.86. What is the ratio of the Female students (as % of total students) in Latvia in 2004 to that in 2009?
Provide a short and direct response. 0.94. What is the ratio of the Female students (as % of total students) in Turkey in 2004 to that in 2009?
Keep it short and to the point. 0.74. What is the ratio of the Female students (as % of total students) of Euro area in 2004 to that in 2010?
Provide a succinct answer. 1.03. What is the ratio of the Female students (as % of total students) of Cabo Verde in 2004 to that in 2010?
Your response must be concise. 0.81. What is the ratio of the Female students (as % of total students) of Latvia in 2004 to that in 2010?
Your answer should be compact. 0.97. What is the ratio of the Female students (as % of total students) in Turkey in 2004 to that in 2010?
Your response must be concise. 0.74. What is the ratio of the Female students (as % of total students) of Euro area in 2005 to that in 2006?
Provide a succinct answer. 1.01. What is the ratio of the Female students (as % of total students) in Latvia in 2005 to that in 2006?
Your answer should be very brief. 0.98. What is the ratio of the Female students (as % of total students) of Turkey in 2005 to that in 2006?
Offer a very short reply. 1. What is the ratio of the Female students (as % of total students) of Euro area in 2005 to that in 2007?
Offer a terse response. 1.01. What is the ratio of the Female students (as % of total students) in Cabo Verde in 2005 to that in 2007?
Your response must be concise. 0.96. What is the ratio of the Female students (as % of total students) of Latvia in 2005 to that in 2007?
Keep it short and to the point. 0.96. What is the ratio of the Female students (as % of total students) in Turkey in 2005 to that in 2007?
Offer a terse response. 0.97. What is the ratio of the Female students (as % of total students) in Euro area in 2005 to that in 2008?
Your answer should be very brief. 1.02. What is the ratio of the Female students (as % of total students) of Cabo Verde in 2005 to that in 2008?
Provide a short and direct response. 0.94. What is the ratio of the Female students (as % of total students) of Latvia in 2005 to that in 2008?
Keep it short and to the point. 0.95. What is the ratio of the Female students (as % of total students) in Turkey in 2005 to that in 2008?
Your answer should be compact. 0.92. What is the ratio of the Female students (as % of total students) of Euro area in 2005 to that in 2009?
Offer a terse response. 1.03. What is the ratio of the Female students (as % of total students) of Cabo Verde in 2005 to that in 2009?
Keep it short and to the point. 0.89. What is the ratio of the Female students (as % of total students) of Latvia in 2005 to that in 2009?
Your answer should be compact. 0.95. What is the ratio of the Female students (as % of total students) of Turkey in 2005 to that in 2009?
Keep it short and to the point. 0.89. What is the ratio of the Female students (as % of total students) in Euro area in 2005 to that in 2010?
Your response must be concise. 1.03. What is the ratio of the Female students (as % of total students) in Cabo Verde in 2005 to that in 2010?
Offer a very short reply. 0.85. What is the ratio of the Female students (as % of total students) of Turkey in 2005 to that in 2010?
Your response must be concise. 0.88. What is the ratio of the Female students (as % of total students) in Cabo Verde in 2006 to that in 2007?
Make the answer very short. 0.99. What is the ratio of the Female students (as % of total students) of Latvia in 2006 to that in 2007?
Offer a very short reply. 0.98. What is the ratio of the Female students (as % of total students) of Turkey in 2006 to that in 2007?
Provide a short and direct response. 0.98. What is the ratio of the Female students (as % of total students) of Euro area in 2006 to that in 2008?
Provide a succinct answer. 1. What is the ratio of the Female students (as % of total students) in Cabo Verde in 2006 to that in 2008?
Your response must be concise. 0.97. What is the ratio of the Female students (as % of total students) of Latvia in 2006 to that in 2008?
Offer a terse response. 0.97. What is the ratio of the Female students (as % of total students) in Turkey in 2006 to that in 2008?
Your response must be concise. 0.92. What is the ratio of the Female students (as % of total students) of Euro area in 2006 to that in 2009?
Your response must be concise. 1.02. What is the ratio of the Female students (as % of total students) of Cabo Verde in 2006 to that in 2009?
Make the answer very short. 0.92. What is the ratio of the Female students (as % of total students) of Latvia in 2006 to that in 2009?
Your answer should be compact. 0.96. What is the ratio of the Female students (as % of total students) of Turkey in 2006 to that in 2009?
Offer a very short reply. 0.89. What is the ratio of the Female students (as % of total students) in Euro area in 2006 to that in 2010?
Your answer should be very brief. 1.01. What is the ratio of the Female students (as % of total students) in Cabo Verde in 2006 to that in 2010?
Ensure brevity in your answer.  0.87. What is the ratio of the Female students (as % of total students) in Turkey in 2006 to that in 2010?
Offer a very short reply. 0.89. What is the ratio of the Female students (as % of total students) of Cabo Verde in 2007 to that in 2008?
Ensure brevity in your answer.  0.98. What is the ratio of the Female students (as % of total students) in Turkey in 2007 to that in 2008?
Your answer should be compact. 0.94. What is the ratio of the Female students (as % of total students) in Euro area in 2007 to that in 2009?
Make the answer very short. 1.02. What is the ratio of the Female students (as % of total students) in Cabo Verde in 2007 to that in 2009?
Make the answer very short. 0.93. What is the ratio of the Female students (as % of total students) in Turkey in 2007 to that in 2009?
Make the answer very short. 0.91. What is the ratio of the Female students (as % of total students) of Euro area in 2007 to that in 2010?
Ensure brevity in your answer.  1.01. What is the ratio of the Female students (as % of total students) in Cabo Verde in 2007 to that in 2010?
Keep it short and to the point. 0.88. What is the ratio of the Female students (as % of total students) in Latvia in 2007 to that in 2010?
Give a very brief answer. 1.02. What is the ratio of the Female students (as % of total students) in Turkey in 2007 to that in 2010?
Offer a very short reply. 0.91. What is the ratio of the Female students (as % of total students) in Euro area in 2008 to that in 2009?
Your answer should be very brief. 1.02. What is the ratio of the Female students (as % of total students) of Cabo Verde in 2008 to that in 2009?
Your response must be concise. 0.95. What is the ratio of the Female students (as % of total students) in Turkey in 2008 to that in 2009?
Ensure brevity in your answer.  0.97. What is the ratio of the Female students (as % of total students) of Euro area in 2008 to that in 2010?
Your answer should be compact. 1.01. What is the ratio of the Female students (as % of total students) in Cabo Verde in 2008 to that in 2010?
Your answer should be compact. 0.9. What is the ratio of the Female students (as % of total students) in Latvia in 2008 to that in 2010?
Ensure brevity in your answer.  1.03. What is the ratio of the Female students (as % of total students) in Turkey in 2008 to that in 2010?
Offer a very short reply. 0.96. What is the ratio of the Female students (as % of total students) of Euro area in 2009 to that in 2010?
Your answer should be compact. 0.99. What is the ratio of the Female students (as % of total students) of Cabo Verde in 2009 to that in 2010?
Your answer should be very brief. 0.95. What is the ratio of the Female students (as % of total students) of Latvia in 2009 to that in 2010?
Ensure brevity in your answer.  1.03. What is the ratio of the Female students (as % of total students) of Turkey in 2009 to that in 2010?
Give a very brief answer. 1. What is the difference between the highest and the second highest Female students (as % of total students) of Euro area?
Give a very brief answer. 0.08. What is the difference between the highest and the second highest Female students (as % of total students) of Cabo Verde?
Ensure brevity in your answer.  2.46. What is the difference between the highest and the second highest Female students (as % of total students) in Latvia?
Offer a very short reply. 0.17. What is the difference between the highest and the second highest Female students (as % of total students) of Turkey?
Your answer should be compact. 0.08. What is the difference between the highest and the lowest Female students (as % of total students) in Euro area?
Give a very brief answer. 1.42. What is the difference between the highest and the lowest Female students (as % of total students) in Cabo Verde?
Give a very brief answer. 9.04. What is the difference between the highest and the lowest Female students (as % of total students) of Latvia?
Your answer should be very brief. 2.39. What is the difference between the highest and the lowest Female students (as % of total students) of Turkey?
Provide a short and direct response. 10.96. 